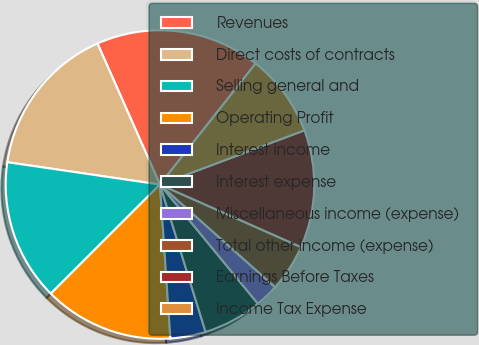Convert chart to OTSL. <chart><loc_0><loc_0><loc_500><loc_500><pie_chart><fcel>Revenues<fcel>Direct costs of contracts<fcel>Selling general and<fcel>Operating Profit<fcel>Interest income<fcel>Interest expense<fcel>Miscellaneous income (expense)<fcel>Total other income (expense)<fcel>Earnings Before Taxes<fcel>Income Tax Expense<nl><fcel>17.28%<fcel>16.05%<fcel>14.81%<fcel>13.58%<fcel>3.7%<fcel>6.17%<fcel>2.47%<fcel>4.94%<fcel>12.35%<fcel>8.64%<nl></chart> 